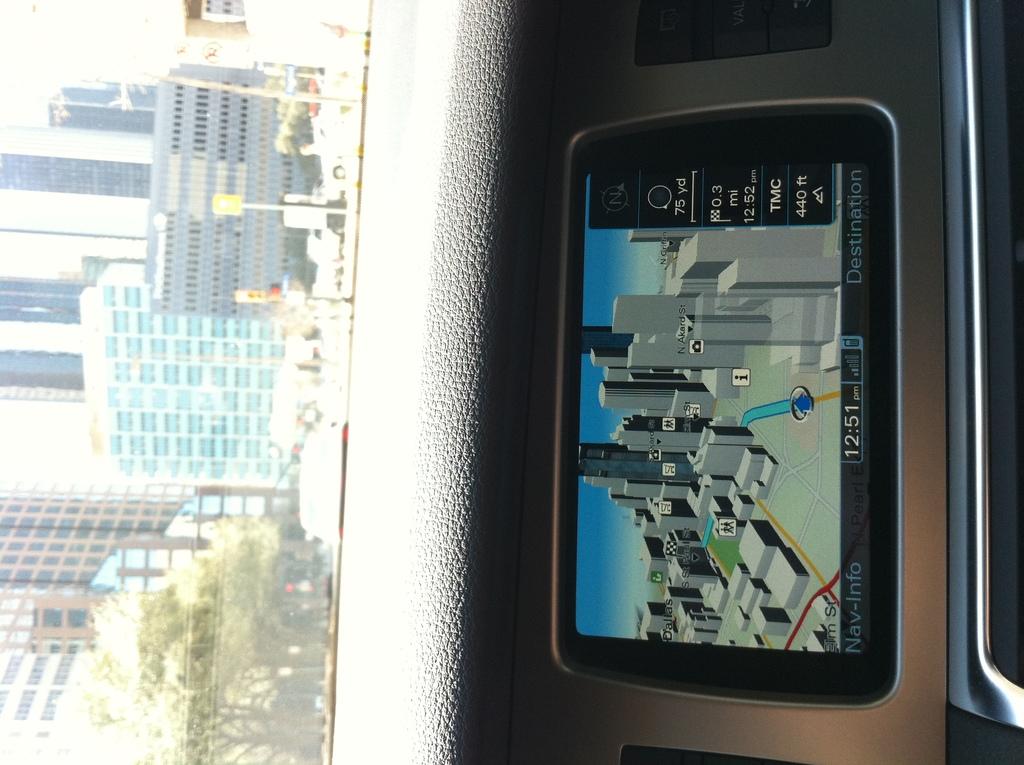What time is shown on the gps?
Keep it short and to the point. 12:51. What time is on the phone?
Make the answer very short. 12:51. 